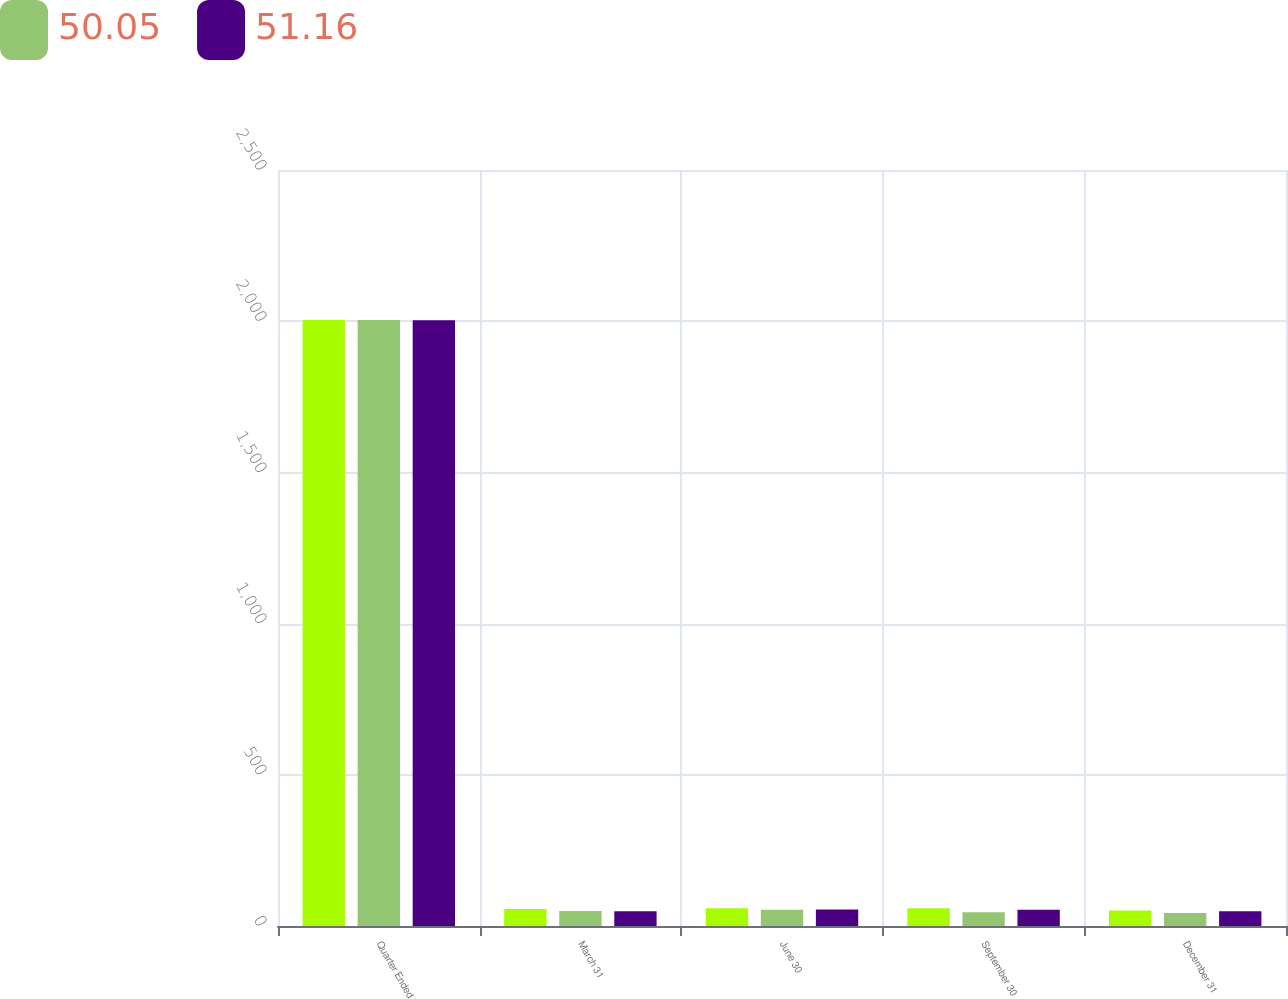Convert chart to OTSL. <chart><loc_0><loc_0><loc_500><loc_500><stacked_bar_chart><ecel><fcel>Quarter Ended<fcel>March 31<fcel>June 30<fcel>September 30<fcel>December 31<nl><fcel>nan<fcel>2004<fcel>56.55<fcel>58.92<fcel>58.73<fcel>51.26<nl><fcel>50.05<fcel>2004<fcel>49.62<fcel>53.56<fcel>45.15<fcel>43.06<nl><fcel>51.16<fcel>2003<fcel>49.1<fcel>54.52<fcel>53.35<fcel>49.13<nl></chart> 